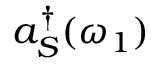Convert formula to latex. <formula><loc_0><loc_0><loc_500><loc_500>a _ { S } ^ { \dagger } ( \omega _ { 1 } )</formula> 